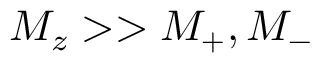Convert formula to latex. <formula><loc_0><loc_0><loc_500><loc_500>{ M _ { z } > > M _ { + } , M _ { - } }</formula> 